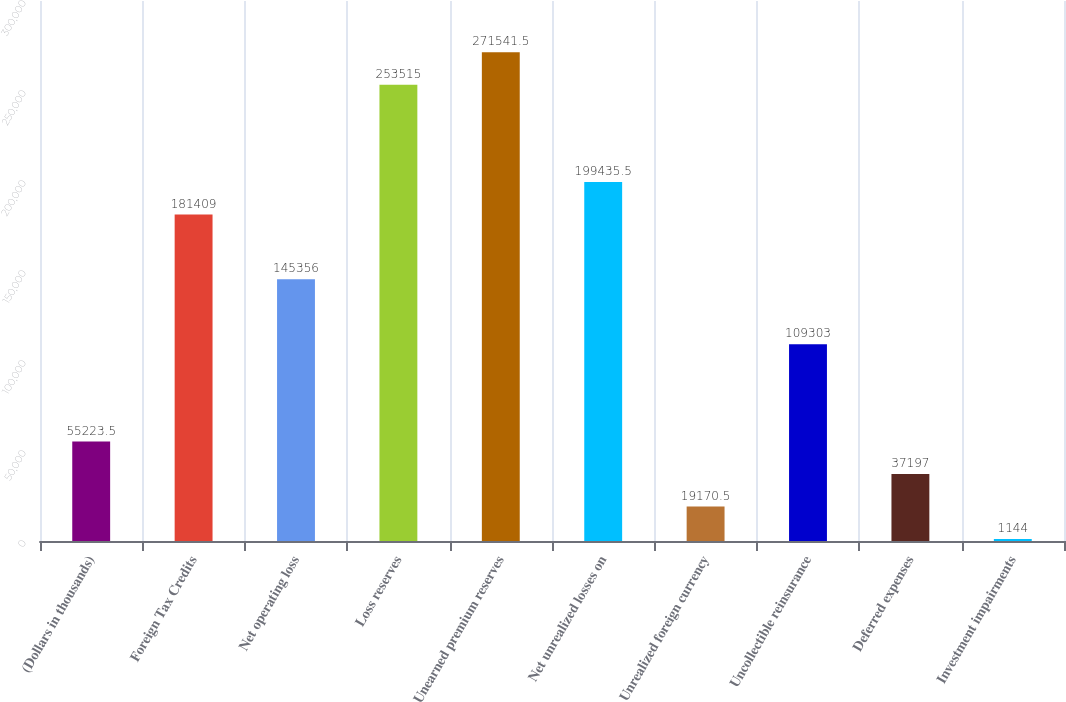<chart> <loc_0><loc_0><loc_500><loc_500><bar_chart><fcel>(Dollars in thousands)<fcel>Foreign Tax Credits<fcel>Net operating loss<fcel>Loss reserves<fcel>Unearned premium reserves<fcel>Net unrealized losses on<fcel>Unrealized foreign currency<fcel>Uncollectible reinsurance<fcel>Deferred expenses<fcel>Investment impairments<nl><fcel>55223.5<fcel>181409<fcel>145356<fcel>253515<fcel>271542<fcel>199436<fcel>19170.5<fcel>109303<fcel>37197<fcel>1144<nl></chart> 